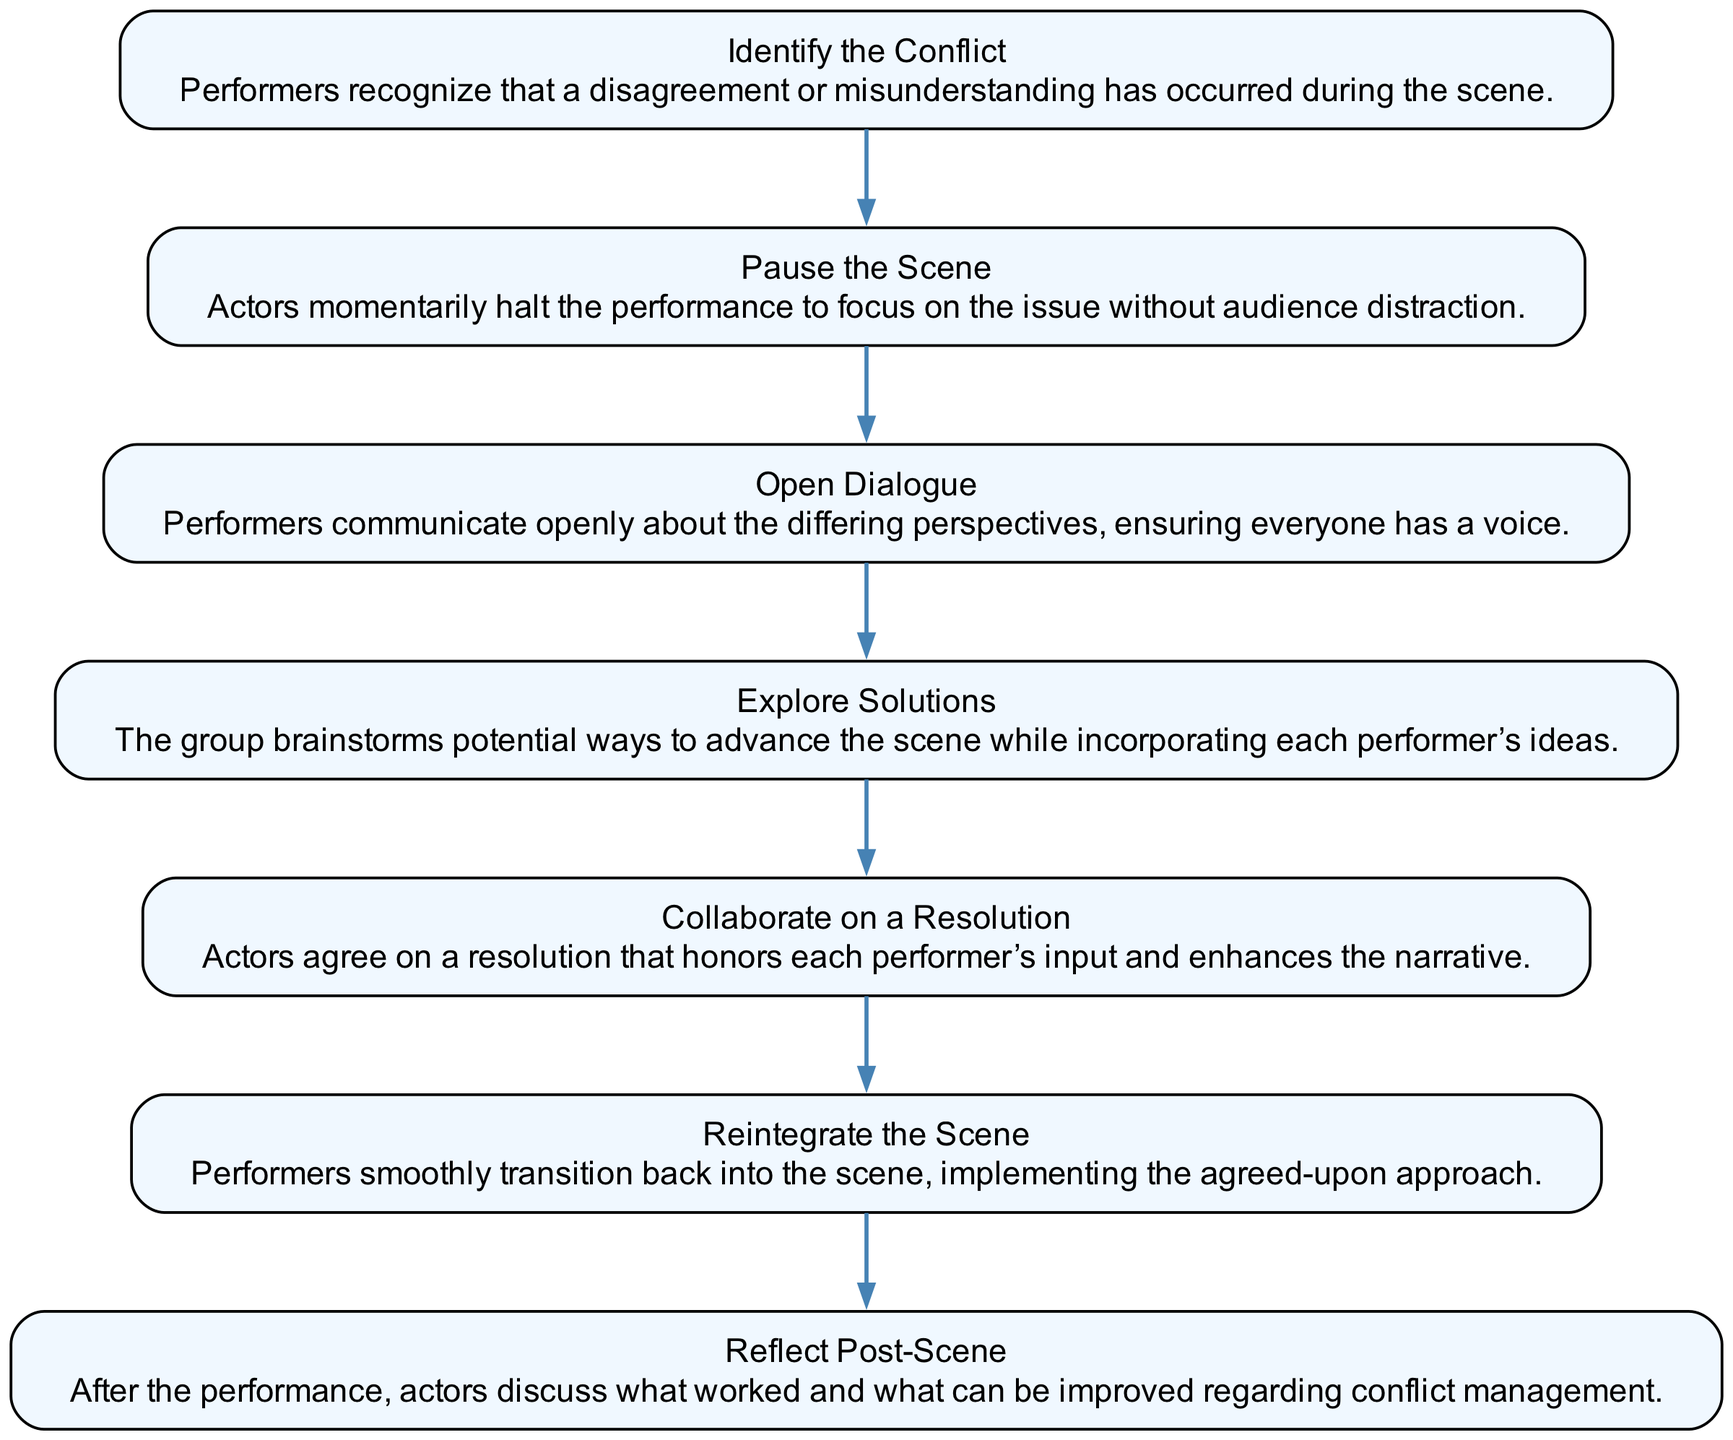What is the first step in the conflict resolution process? The first step listed in the diagram is "Identify the Conflict," which highlights the initial action performers take to recognize a disagreement has occurred during the scene.
Answer: Identify the Conflict How many steps are there in total? The diagram contains seven distinct steps in the conflict resolution process, as indicated by the individual nodes representing each step.
Answer: Seven What step follows "Open Dialogue"? After "Open Dialogue," the next step listed in the sequence is "Explore Solutions," where the group brainstorms potential ways to advance the scene.
Answer: Explore Solutions Which step emphasizes the importance of communication? The step "Open Dialogue" focuses on communication, ensuring that all performers can express their differing perspectives during the resolution process.
Answer: Open Dialogue What is the last step after the scene ends? The final step in the sequence is "Reflect Post-Scene," which involves discussions among actors about what strategies worked regarding conflict management after the performance.
Answer: Reflect Post-Scene How many steps focus on collaboration or agreement? The steps "Collaborate on a Resolution" and "Open Dialogue" both highlight collaborative aspects, making a total of two steps that focus on working together to resolve the conflict.
Answer: Two Which step involves halting the performance? "Pause the Scene" is the step that instructs performers to momentarily halt their performance to address the conflict without audience distraction.
Answer: Pause the Scene What is the core objective of "Explore Solutions"? The core objective of "Explore Solutions" is for the group to brainstorm potential ways to advance the scene while incorporating each performer’s ideas, therefore promoting inclusivity.
Answer: Brainstorm solutions 